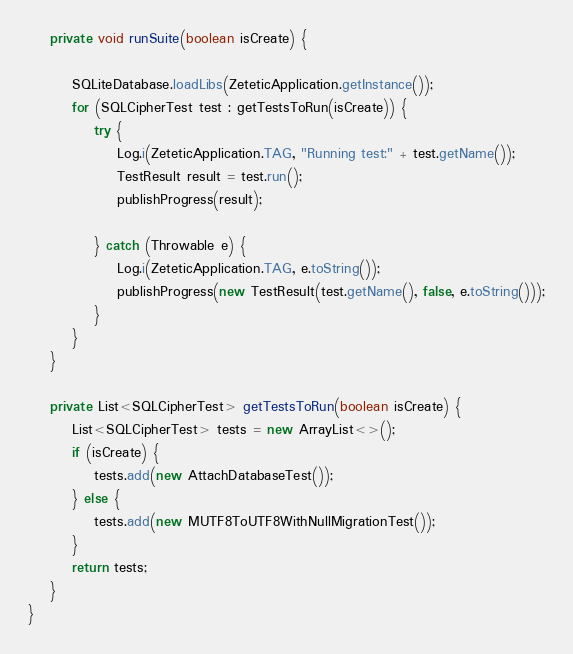Convert code to text. <code><loc_0><loc_0><loc_500><loc_500><_Java_>    private void runSuite(boolean isCreate) {

        SQLiteDatabase.loadLibs(ZeteticApplication.getInstance());
        for (SQLCipherTest test : getTestsToRun(isCreate)) {
            try {
                Log.i(ZeteticApplication.TAG, "Running test:" + test.getName());
                TestResult result = test.run();
                publishProgress(result);

            } catch (Throwable e) {
                Log.i(ZeteticApplication.TAG, e.toString());
                publishProgress(new TestResult(test.getName(), false, e.toString()));
            }
        }
    }

    private List<SQLCipherTest> getTestsToRun(boolean isCreate) {
        List<SQLCipherTest> tests = new ArrayList<>();
        if (isCreate) {
            tests.add(new AttachDatabaseTest());
        } else {
            tests.add(new MUTF8ToUTF8WithNullMigrationTest());
        }
        return tests;
    }
}
</code> 